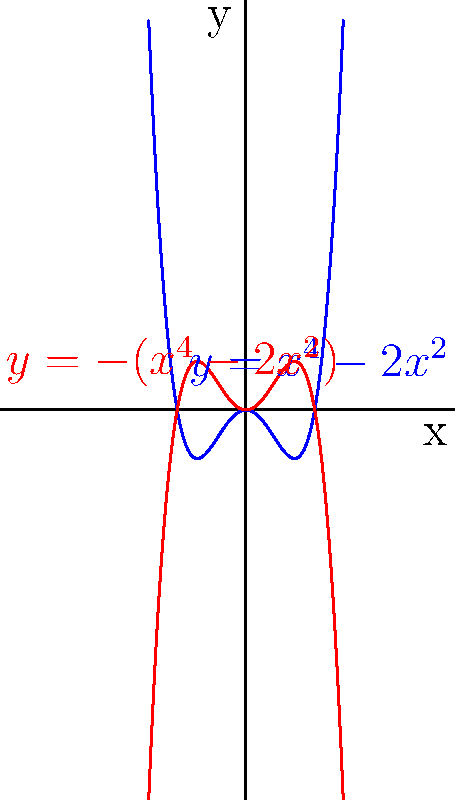As a supermodel, you're collaborating with a designer on a symmetrical fabric pattern. The designer shows you the graph above, representing two polynomial functions: $y=x^4-2x^2$ (blue) and $y=-(x^4-2x^2)$ (red). Which of these functions would create a more visually appealing symmetrical pattern for a runway outfit, and why? To determine which function would create a more visually appealing symmetrical pattern, we need to analyze the properties of each function:

1. Both functions are even functions, as $f(-x) = f(x)$ for all x. This means they are symmetrical about the y-axis.

2. The blue function $y=x^4-2x^2$:
   - Has a "W" shape
   - Has three turning points: a local maximum at (0,0) and two local minima at $(\pm 1, -1)$
   - Extends upwards as $|x|$ increases

3. The red function $y=-(x^4-2x^2)$:
   - Has an "M" shape
   - Has three turning points: a local minimum at (0,0) and two local maxima at $(\pm 1, 1)$
   - Extends downwards as $|x|$ increases

4. For fabric design:
   - The red function creates a more enclosed, bowl-like shape, which could be more suitable for repeated patterns in fabric design.
   - The "M" shape of the red function provides a more balanced and contained look, potentially creating a more harmonious repeating pattern.
   - The upward curves of the red function at the edges could create interesting transitions between repeated motifs in the fabric design.

5. From a runway perspective:
   - The red function's curves might better accentuate and complement body contours.
   - The more compact shape of the red function could create a more cohesive and visually striking pattern when viewed from a distance on the runway.

Therefore, the red function $y=-(x^4-2x^2)$ would likely create a more visually appealing symmetrical pattern for a runway outfit due to its balanced shape and potential for creating harmonious, body-complementing designs.
Answer: $y=-(x^4-2x^2)$ (red function) 